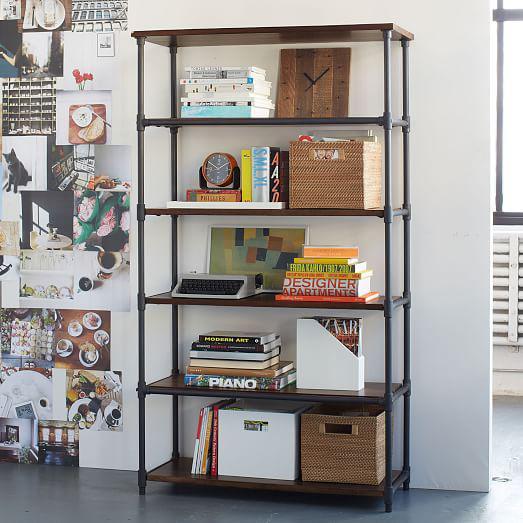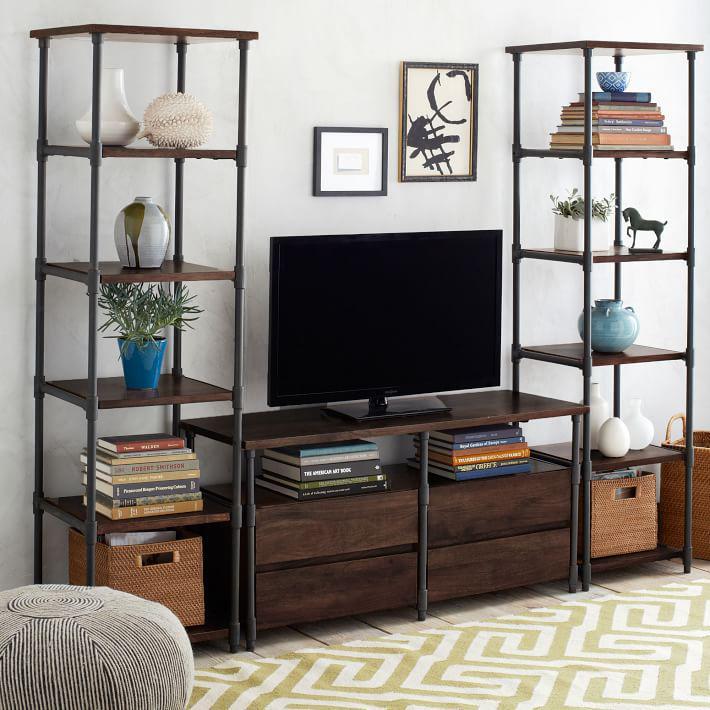The first image is the image on the left, the second image is the image on the right. Considering the images on both sides, is "An image shows a completely empty set of shelves." valid? Answer yes or no. No. The first image is the image on the left, the second image is the image on the right. Given the left and right images, does the statement "One of the images shows a bookshelf that is empty." hold true? Answer yes or no. No. 